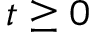Convert formula to latex. <formula><loc_0><loc_0><loc_500><loc_500>t \geq 0</formula> 